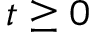Convert formula to latex. <formula><loc_0><loc_0><loc_500><loc_500>t \geq 0</formula> 